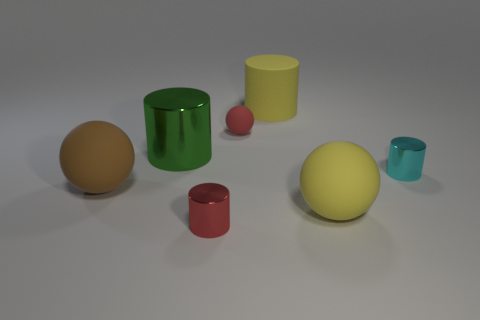Is the number of brown things greater than the number of small cyan matte blocks?
Make the answer very short. Yes. There is a metallic thing right of the red object that is in front of the big metal cylinder; what is its size?
Provide a short and direct response. Small. The other small shiny thing that is the same shape as the cyan object is what color?
Your answer should be very brief. Red. The red ball has what size?
Provide a succinct answer. Small. How many cylinders are large blue metallic things or large brown objects?
Provide a succinct answer. 0. What is the size of the other red thing that is the same shape as the large metal object?
Ensure brevity in your answer.  Small. How many red metal spheres are there?
Your answer should be compact. 0. Do the red shiny thing and the large yellow object that is behind the green object have the same shape?
Offer a very short reply. Yes. There is a shiny object that is on the right side of the big yellow sphere; what is its size?
Offer a very short reply. Small. What material is the big green object?
Your answer should be very brief. Metal. 